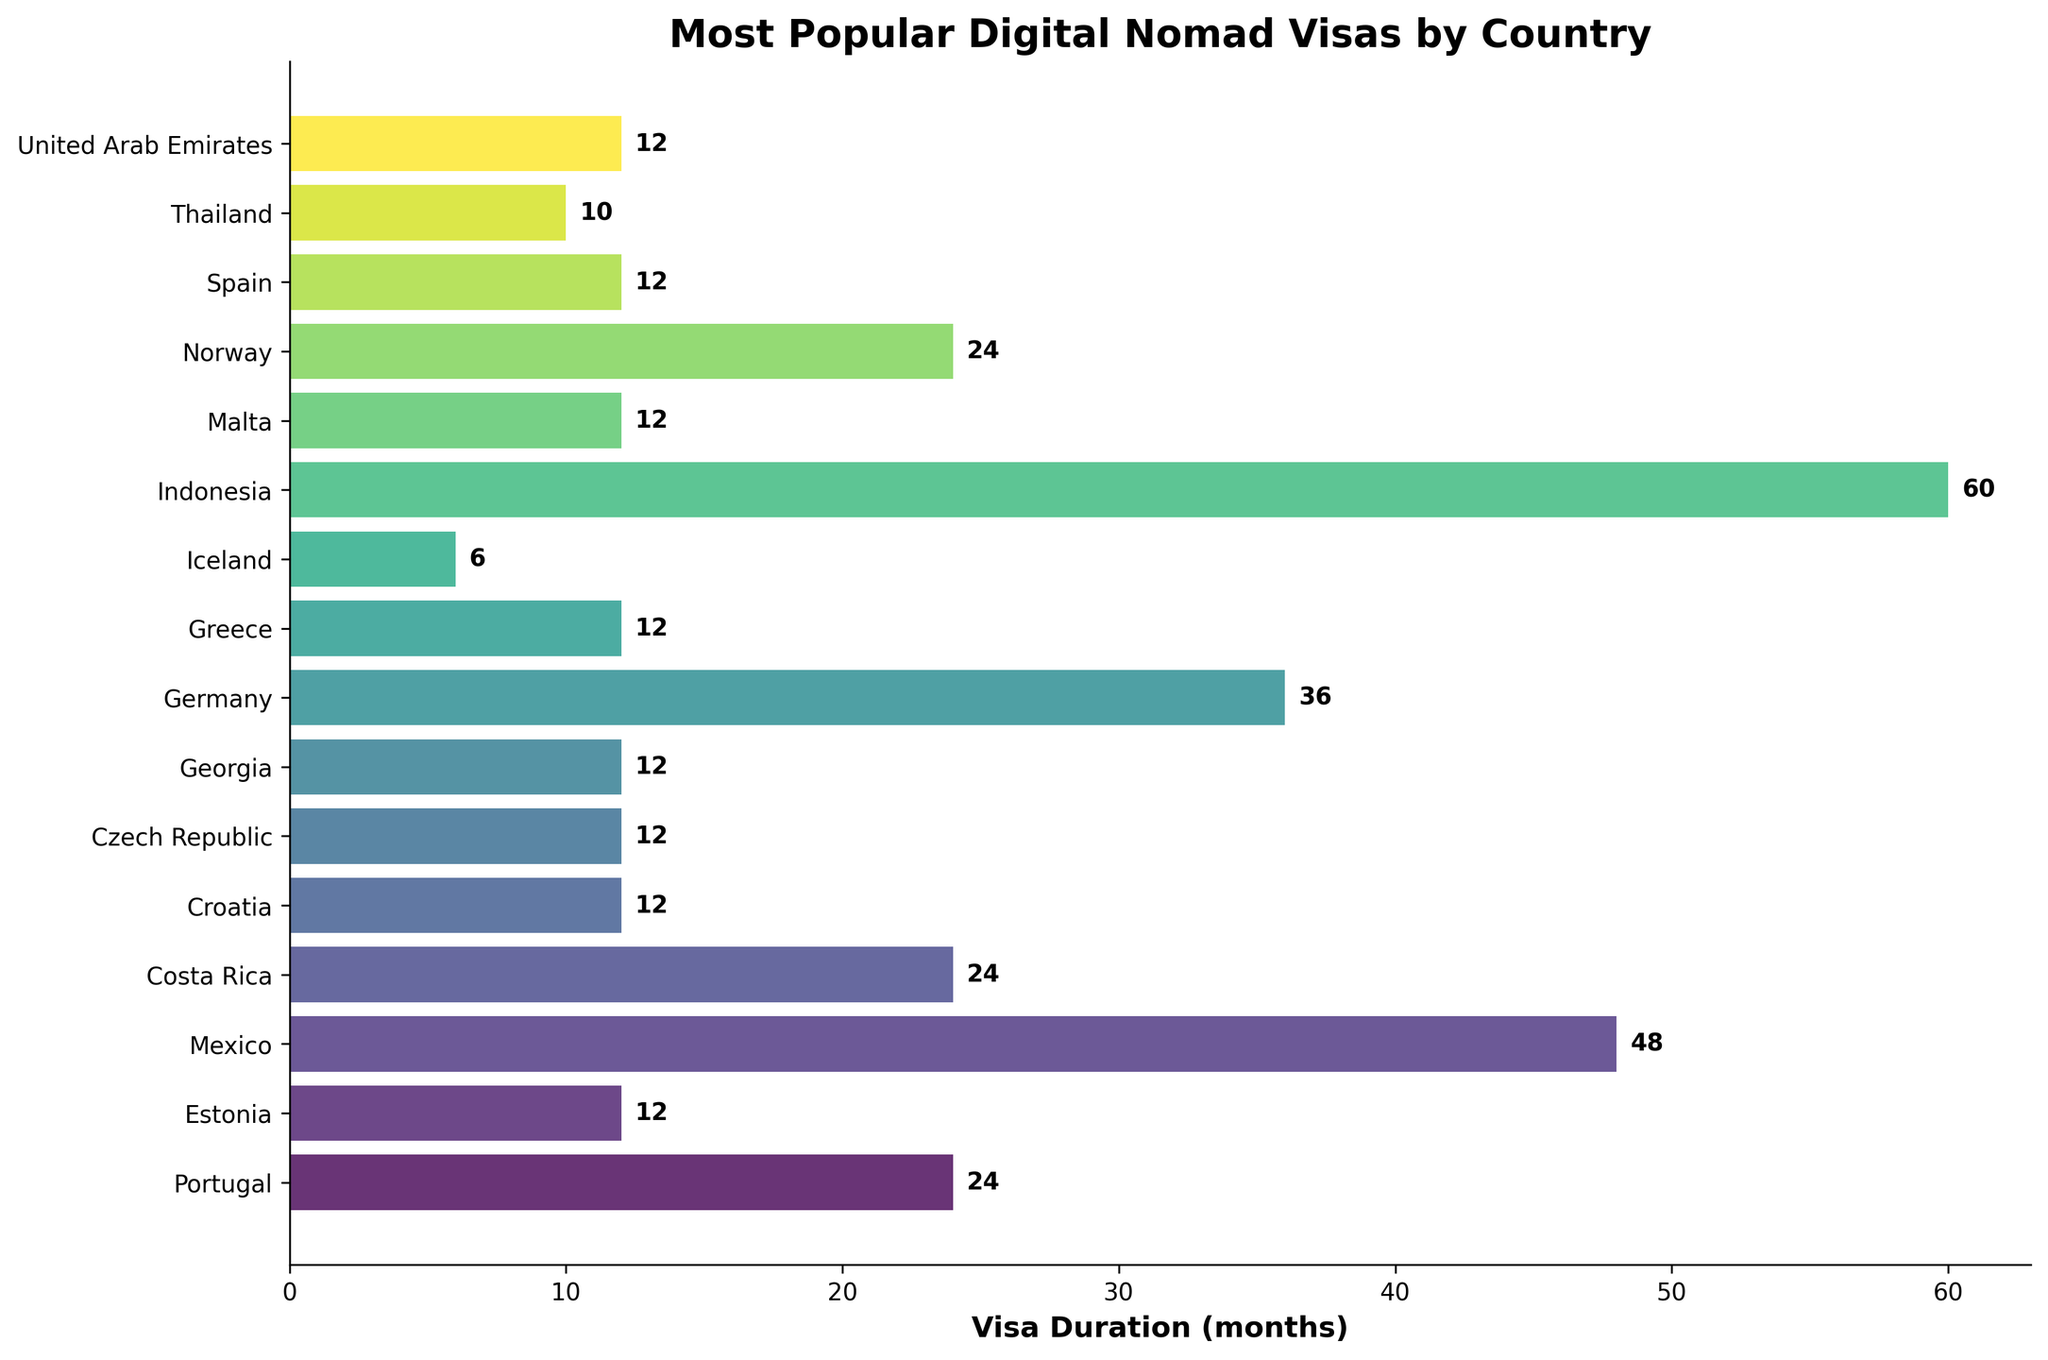Which country offers the digital nomad visa with the longest duration? By scanning the length of the bars representing each country on the chart, Indonesia has the longest bar, indicating the longest visa duration of 60 months.
Answer: Indonesia How many countries offer a digital nomad visa duration of 12 months? Count the number of bars that correspond to a duration of 12 months. Estonia, Croatia, Czech Republic, Georgia, Greece, Malta, Spain, and the United Arab Emirates each offer a 12-month visa. This totals to 8 countries.
Answer: 8 Which countries provide digital nomad visas for more than 2 years? Look for bars that are longer than the 24-month mark. The countries with visa durations greater than 24 months are Mexico (48 months), Germany (36 months), and Indonesia (60 months).
Answer: Mexico, Germany, Indonesia Compare the visa duration between Portugal and Iceland. Which one is longer? Locate both the bars corresponding to Portugal and Iceland on the chart and compare their lengths. Portugal's bar represents a 24-month visa while Iceland's represents a 6-month visa. Portugal offers a longer visa duration than Iceland.
Answer: Portugal What is the average duration of digital nomad visas offered by the countries shown on the chart? Calculate the average by summing the durations and dividing by the number of countries. The total duration is 12 + 10 + 12 + 24 + 48 + 12 + 24 + 36 + 12 + 24 + 6 + 12 + 12 + 12 + 60 + 12 = 322. There are 16 countries, so the average is 322/16 = 20.125 months.
Answer: 20.125 months Which country offers the shortest digital nomad visa duration? Check the chart for the shortest bar, which corresponds to the duration offered by Iceland, at 6 months.
Answer: Iceland Among the European countries listed, which one offers the longest digital nomad visa duration? Identify European countries and compare their visa durations: Portugal (24 months), Estonia (12 months), Croatia (12 months), Czech Republic (12 months), Germany (36 months), Greece (12 months), Iceland (6 months), Malta (12 months), Norway (24 months), Spain (12 months). Germany, with 36 months, offers the longest visa among European countries.
Answer: Germany 